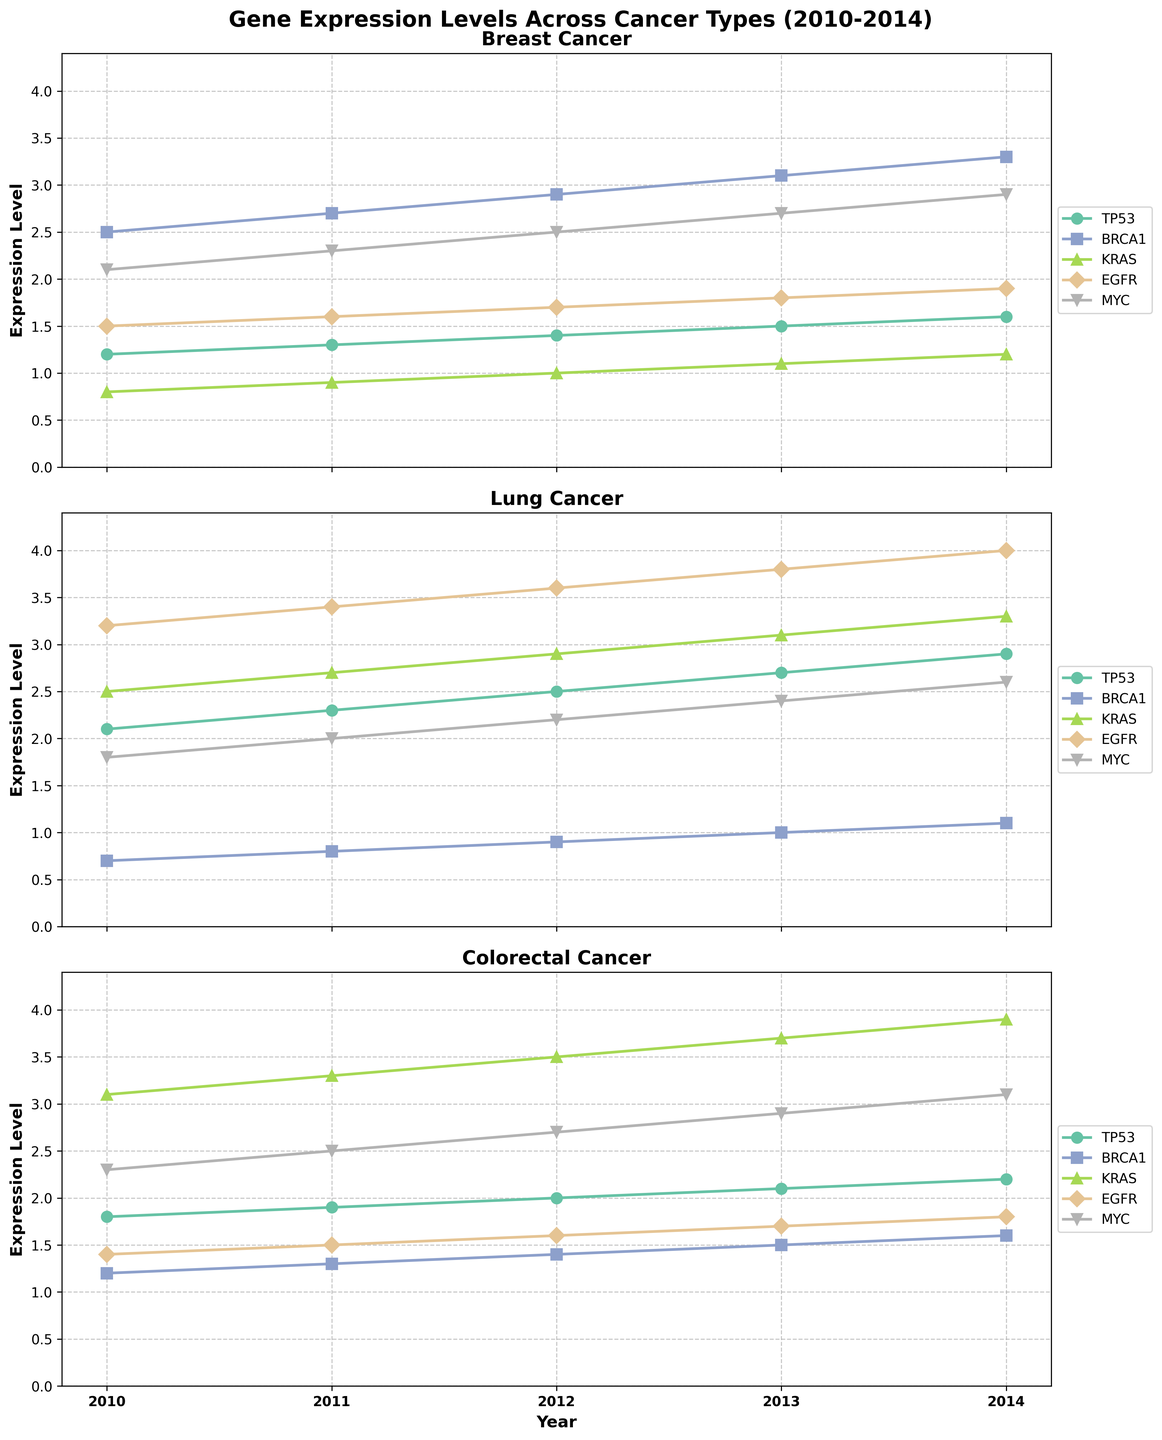What is the title of the figure? The title is present at the top of the plot in a large, bold font.
Answer: Gene Expression Levels Across Cancer Types (2010-2014) How many cancer types are depicted in the figure? The figure contains subplots for each cancer type, which can be seen by the title in each subplot.
Answer: 3 Which gene has the highest expression level for Lung Cancer in 2014? By looking at the Lung Cancer subplot and observing the end of the lines for 2014, the gene with the highest value can be identified.
Answer: EGFR What is the average expression level of MYC across all cancer types in 2010? For each cancer type, find the expression level of MYC in 2010 and calculate the average. Breast Cancer: 2.1, Lung Cancer: 1.8, Colorectal Cancer: 2.3. Average = (2.1 + 1.8 + 2.3) / 3 = 2.0667
Answer: 2.07 Which gene shows a consistent increase in expression levels over time across all cancer types? Check the trend of each gene over time in all the subplots and identify which gene consistently increases.
Answer: TP53 In which year did BRCA1 have the smallest expression level in Colorectal Cancer? Look at the line for BRCA1 in the Colorectal Cancer subplot and identify the year with the lowest value.
Answer: 2010 What is the difference in KRAS expression levels between Breast Cancer and Lung Cancer in 2012? Find KRAS expression levels for both cancers in 2012: Breast Cancer: 1.0, Lung Cancer: 2.9. Calculate the difference: 2.9 - 1.0 = 1.9
Answer: 1.9 Which cancer type has the highest average MYC expression level over the years? Calculate the average MYC expression for each cancer type from the subplot data and compare the averages. Breast Cancer: (2.1+2.3+2.5+2.7+2.9)/5 = 2.5, Lung Cancer: (1.8+2.0+2.2+2.4+2.6)/5 = 2.2, Colorectal Cancer: (2.3+2.5+2.7+2.9+3.1)/5 = 2.7
Answer: Colorectal Cancer Did expression levels of EGFR in Colorectal Cancer increase or decrease between 2011 and 2014? Locate the values of EGFR in Colorectal Cancer for the years 2011 and 2014 in the subplot and observe the trend. 2011: 1.5, 2014: 1.8. 1.8 > 1.5 which shows an increase.
Answer: Increase Which gene has the most similar expression pattern between Breast Cancer and Lung Cancer? Compare the trends of each gene between Breast Cancer and Lung Cancer subplots to find the most similar patterns.
Answer: TP53 